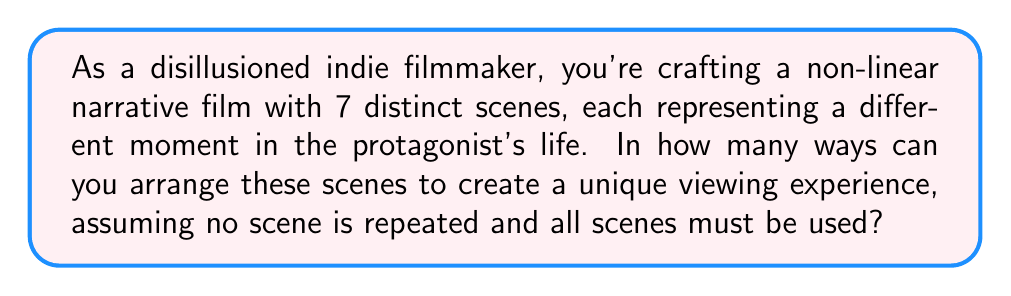Can you solve this math problem? Let's approach this step-by-step:

1) We have 7 distinct scenes, and we want to arrange all of them.

2) This is a perfect scenario for using the concept of permutations.

3) In permutations, the order matters (which is crucial for a non-linear narrative), and we're using all the scenes without repetition.

4) The formula for permutations of n distinct objects is:

   $$P(n) = n!$$

   Where $n!$ represents the factorial of n.

5) In this case, $n = 7$ (the number of scenes).

6) Therefore, the number of possible arrangements is:

   $$P(7) = 7!$$

7) Let's calculate 7!:
   
   $$7! = 7 \times 6 \times 5 \times 4 \times 3 \times 2 \times 1 = 5040$$

This means there are 5040 unique ways to arrange the 7 scenes in your non-linear narrative film, each potentially telling a different story or emphasizing different aspects of the protagonist's life.
Answer: 5040 